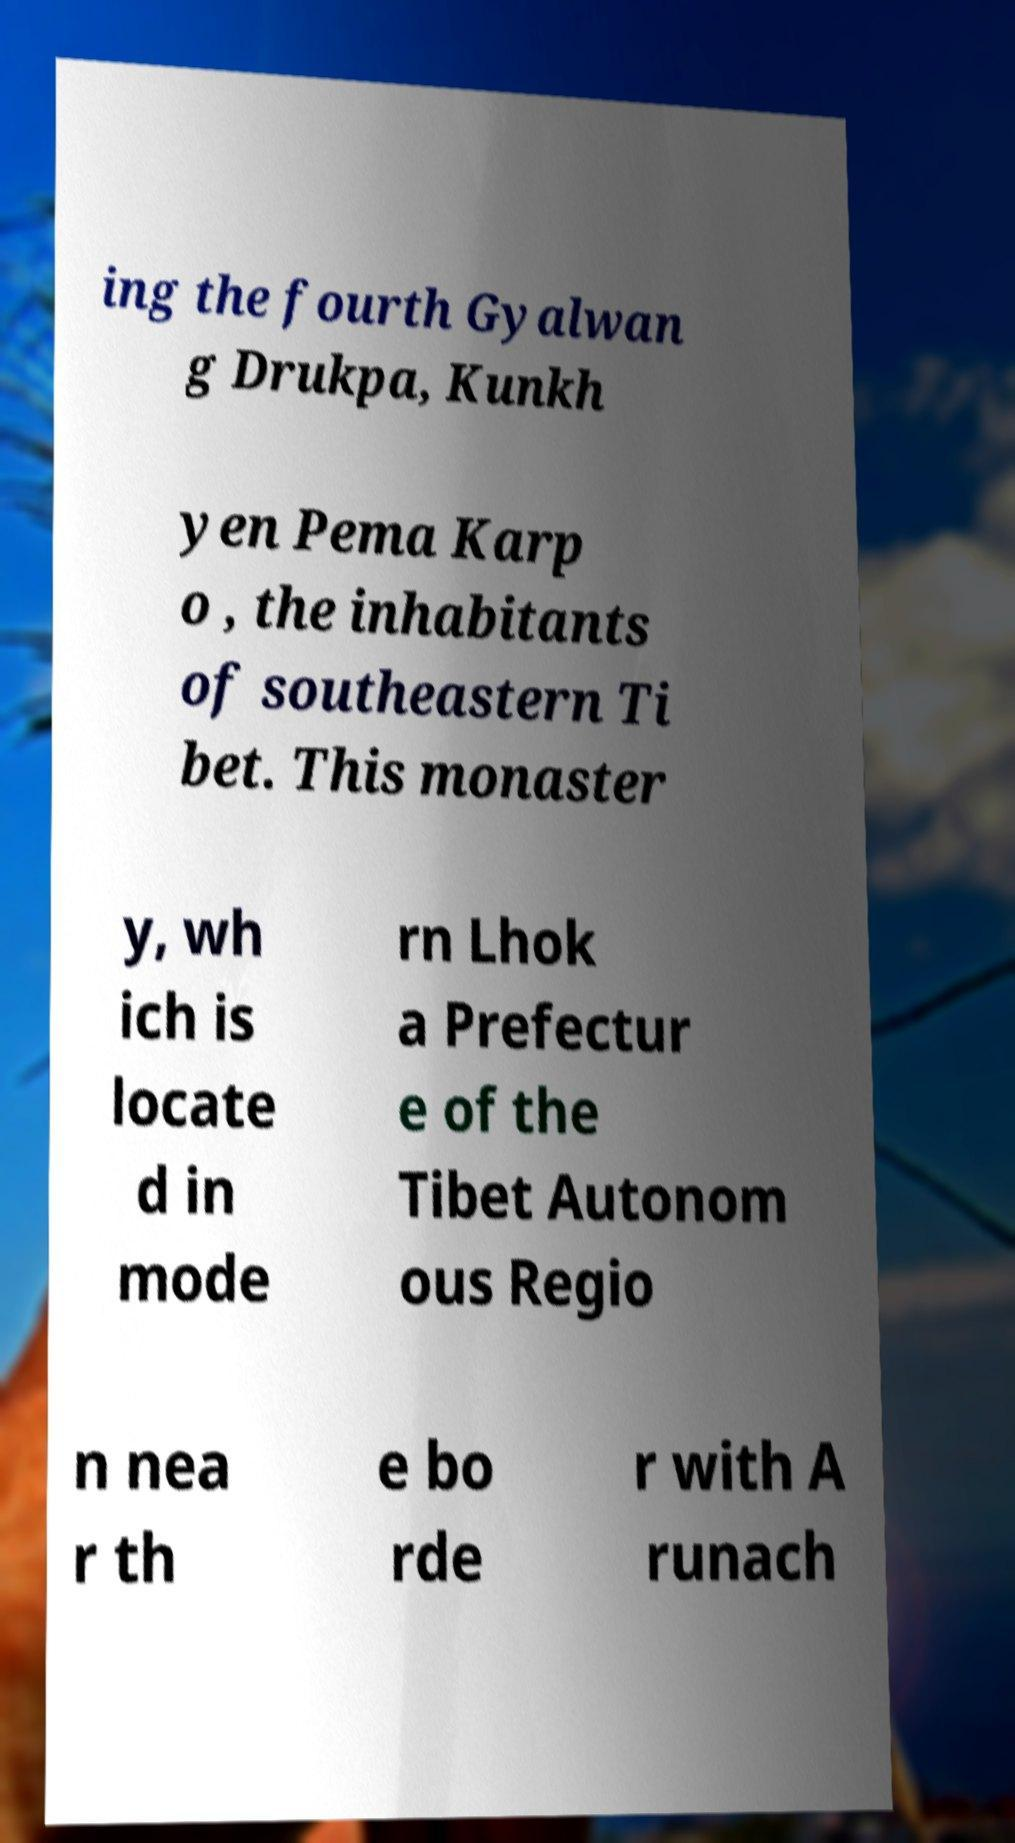Please identify and transcribe the text found in this image. ing the fourth Gyalwan g Drukpa, Kunkh yen Pema Karp o , the inhabitants of southeastern Ti bet. This monaster y, wh ich is locate d in mode rn Lhok a Prefectur e of the Tibet Autonom ous Regio n nea r th e bo rde r with A runach 